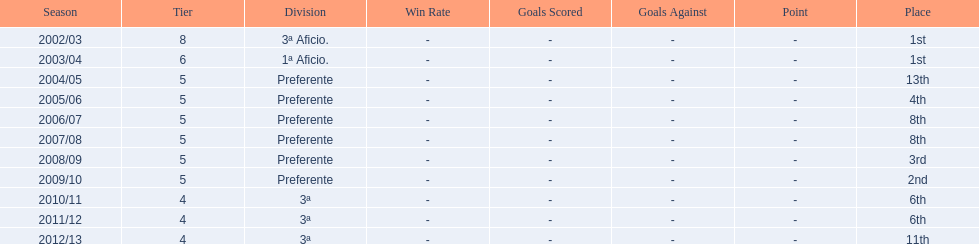Write the full table. {'header': ['Season', 'Tier', 'Division', 'Win Rate', 'Goals Scored', 'Goals Against', 'Point', 'Place'], 'rows': [['2002/03', '8', '3ª Aficio.', '-', '-', '-', '-', '1st'], ['2003/04', '6', '1ª Aficio.', '-', '-', '-', '-', '1st'], ['2004/05', '5', 'Preferente', '-', '-', '-', '-', '13th'], ['2005/06', '5', 'Preferente', '-', '-', '-', '-', '4th'], ['2006/07', '5', 'Preferente', '-', '-', '-', '-', '8th'], ['2007/08', '5', 'Preferente', '-', '-', '-', '-', '8th'], ['2008/09', '5', 'Preferente', '-', '-', '-', '-', '3rd'], ['2009/10', '5', 'Preferente', '-', '-', '-', '-', '2nd'], ['2010/11', '4', '3ª', '-', '-', '-', '-', '6th'], ['2011/12', '4', '3ª', '-', '-', '-', '-', '6th'], ['2012/13', '4', '3ª', '-', '-', '-', '-', '11th']]} How long has internacional de madrid cf been playing in the 3ª division? 3. 